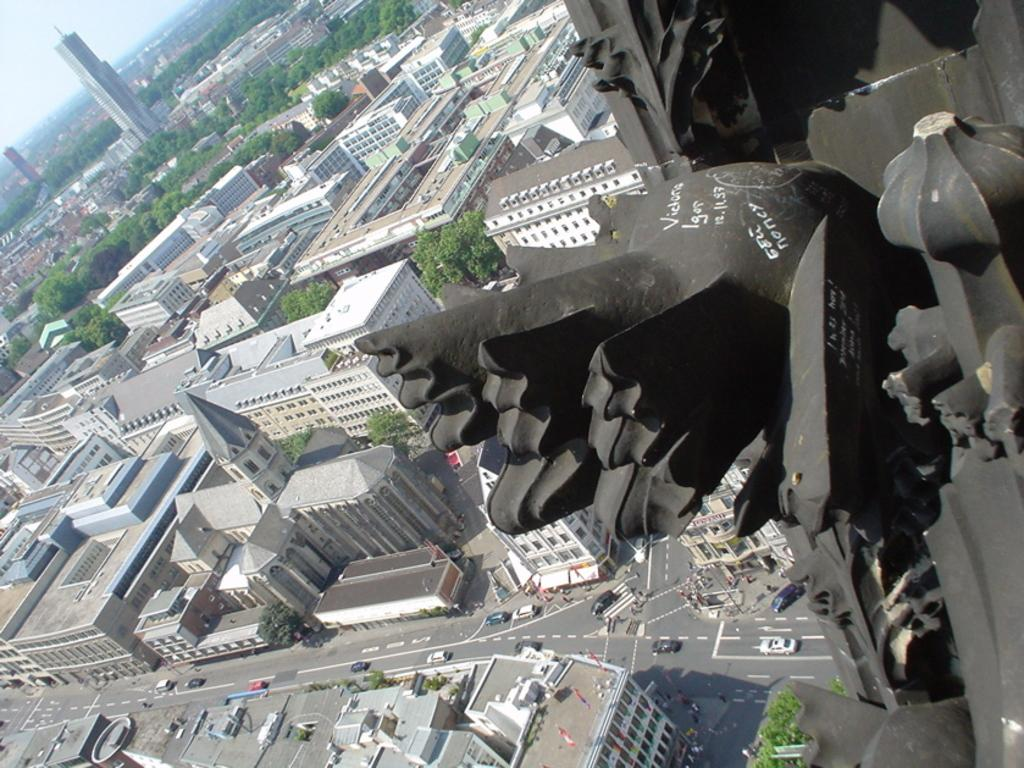What can be seen on the right side of the image? There is a carved stone on the right side of the image. What type of structures are visible in the image? There are buildings in the image. What other natural elements can be seen in the image? Trees are present in the image. What is visible in the background of the image? The sky is visible in the image. What type of transportation is visible in the image? Vehicles are visible in the image. What surface do the vehicles appear to be traveling on? There is a road in the image. Can you tell me how many times the sun talks about credit in the image? There is no sun or mention of credit in the image; it features a carved stone, buildings, trees, the sky, vehicles, and a road. 